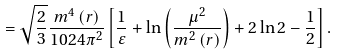<formula> <loc_0><loc_0><loc_500><loc_500>= \sqrt { \frac { 2 } { 3 } } \frac { m ^ { 4 } \left ( r \right ) } { 1 0 2 4 \pi ^ { 2 } } \left [ \frac { 1 } { \varepsilon } + \ln \left ( \frac { \mu ^ { 2 } } { m ^ { 2 } \left ( r \right ) } \right ) + 2 \ln 2 - \frac { 1 } { 2 } \right ] .</formula> 